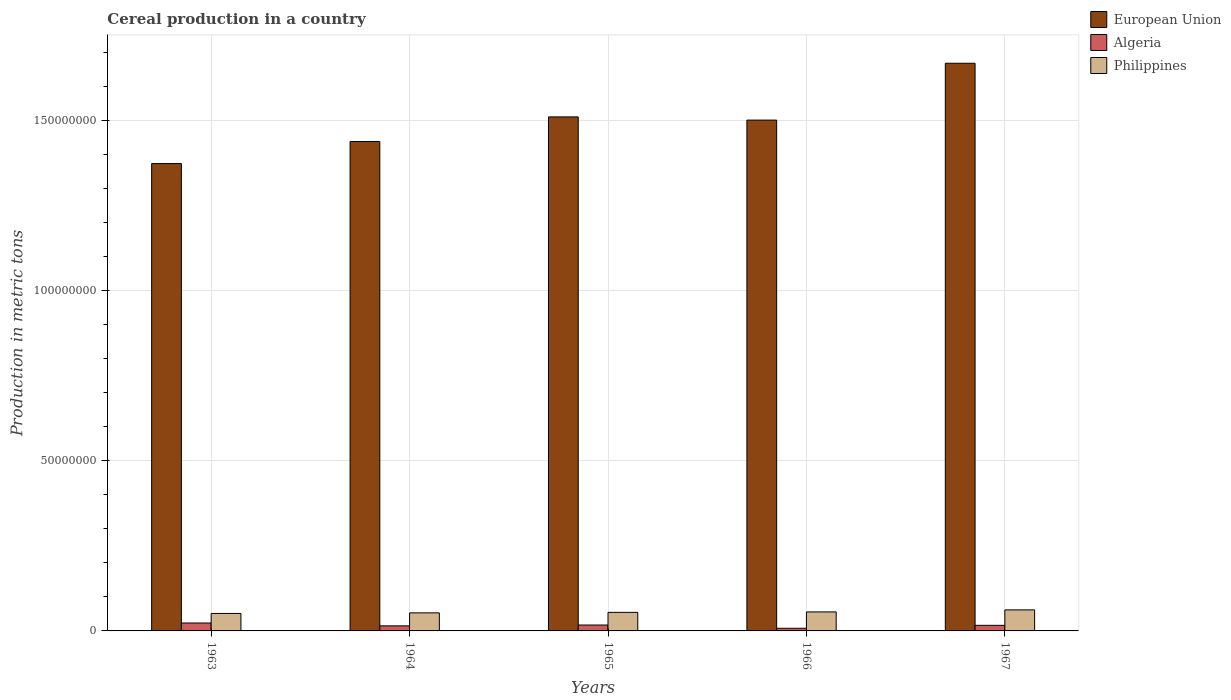How many different coloured bars are there?
Your answer should be compact. 3. Are the number of bars on each tick of the X-axis equal?
Offer a very short reply. Yes. How many bars are there on the 1st tick from the left?
Your response must be concise. 3. How many bars are there on the 2nd tick from the right?
Keep it short and to the point. 3. What is the label of the 3rd group of bars from the left?
Your answer should be compact. 1965. What is the total cereal production in Philippines in 1964?
Keep it short and to the point. 5.31e+06. Across all years, what is the maximum total cereal production in Philippines?
Your answer should be compact. 6.18e+06. Across all years, what is the minimum total cereal production in Philippines?
Your answer should be compact. 5.14e+06. In which year was the total cereal production in Philippines maximum?
Make the answer very short. 1967. What is the total total cereal production in Philippines in the graph?
Ensure brevity in your answer.  2.77e+07. What is the difference between the total cereal production in European Union in 1963 and that in 1966?
Your answer should be very brief. -1.28e+07. What is the difference between the total cereal production in Philippines in 1963 and the total cereal production in Algeria in 1967?
Your answer should be compact. 3.49e+06. What is the average total cereal production in Algeria per year?
Offer a very short reply. 1.59e+06. In the year 1963, what is the difference between the total cereal production in European Union and total cereal production in Philippines?
Make the answer very short. 1.32e+08. In how many years, is the total cereal production in Algeria greater than 60000000 metric tons?
Your response must be concise. 0. What is the ratio of the total cereal production in European Union in 1964 to that in 1965?
Your answer should be very brief. 0.95. Is the difference between the total cereal production in European Union in 1963 and 1965 greater than the difference between the total cereal production in Philippines in 1963 and 1965?
Provide a succinct answer. No. What is the difference between the highest and the second highest total cereal production in Algeria?
Offer a terse response. 5.89e+05. What is the difference between the highest and the lowest total cereal production in European Union?
Offer a terse response. 2.95e+07. Is the sum of the total cereal production in Philippines in 1963 and 1966 greater than the maximum total cereal production in Algeria across all years?
Offer a very short reply. Yes. What does the 2nd bar from the right in 1963 represents?
Ensure brevity in your answer.  Algeria. Is it the case that in every year, the sum of the total cereal production in Philippines and total cereal production in European Union is greater than the total cereal production in Algeria?
Offer a very short reply. Yes. How many years are there in the graph?
Provide a short and direct response. 5. What is the difference between two consecutive major ticks on the Y-axis?
Your answer should be very brief. 5.00e+07. Are the values on the major ticks of Y-axis written in scientific E-notation?
Offer a very short reply. No. Does the graph contain grids?
Make the answer very short. Yes. How many legend labels are there?
Make the answer very short. 3. What is the title of the graph?
Give a very brief answer. Cereal production in a country. Does "Cote d'Ivoire" appear as one of the legend labels in the graph?
Your answer should be very brief. No. What is the label or title of the X-axis?
Offer a very short reply. Years. What is the label or title of the Y-axis?
Your response must be concise. Production in metric tons. What is the Production in metric tons of European Union in 1963?
Your answer should be very brief. 1.37e+08. What is the Production in metric tons in Algeria in 1963?
Keep it short and to the point. 2.32e+06. What is the Production in metric tons of Philippines in 1963?
Keep it short and to the point. 5.14e+06. What is the Production in metric tons of European Union in 1964?
Keep it short and to the point. 1.44e+08. What is the Production in metric tons in Algeria in 1964?
Ensure brevity in your answer.  1.49e+06. What is the Production in metric tons of Philippines in 1964?
Your response must be concise. 5.31e+06. What is the Production in metric tons of European Union in 1965?
Ensure brevity in your answer.  1.51e+08. What is the Production in metric tons in Algeria in 1965?
Your answer should be compact. 1.74e+06. What is the Production in metric tons in Philippines in 1965?
Ensure brevity in your answer.  5.45e+06. What is the Production in metric tons of European Union in 1966?
Provide a short and direct response. 1.50e+08. What is the Production in metric tons in Algeria in 1966?
Your answer should be compact. 7.76e+05. What is the Production in metric tons of Philippines in 1966?
Provide a succinct answer. 5.58e+06. What is the Production in metric tons in European Union in 1967?
Your response must be concise. 1.67e+08. What is the Production in metric tons of Algeria in 1967?
Your response must be concise. 1.64e+06. What is the Production in metric tons of Philippines in 1967?
Offer a very short reply. 6.18e+06. Across all years, what is the maximum Production in metric tons of European Union?
Provide a short and direct response. 1.67e+08. Across all years, what is the maximum Production in metric tons of Algeria?
Offer a terse response. 2.32e+06. Across all years, what is the maximum Production in metric tons in Philippines?
Offer a terse response. 6.18e+06. Across all years, what is the minimum Production in metric tons of European Union?
Ensure brevity in your answer.  1.37e+08. Across all years, what is the minimum Production in metric tons of Algeria?
Provide a short and direct response. 7.76e+05. Across all years, what is the minimum Production in metric tons in Philippines?
Offer a terse response. 5.14e+06. What is the total Production in metric tons in European Union in the graph?
Your response must be concise. 7.49e+08. What is the total Production in metric tons in Algeria in the graph?
Your answer should be compact. 7.97e+06. What is the total Production in metric tons in Philippines in the graph?
Offer a very short reply. 2.77e+07. What is the difference between the Production in metric tons of European Union in 1963 and that in 1964?
Provide a succinct answer. -6.49e+06. What is the difference between the Production in metric tons of Algeria in 1963 and that in 1964?
Keep it short and to the point. 8.37e+05. What is the difference between the Production in metric tons of Philippines in 1963 and that in 1964?
Your answer should be compact. -1.70e+05. What is the difference between the Production in metric tons in European Union in 1963 and that in 1965?
Ensure brevity in your answer.  -1.37e+07. What is the difference between the Production in metric tons of Algeria in 1963 and that in 1965?
Offer a very short reply. 5.89e+05. What is the difference between the Production in metric tons of Philippines in 1963 and that in 1965?
Keep it short and to the point. -3.17e+05. What is the difference between the Production in metric tons in European Union in 1963 and that in 1966?
Provide a succinct answer. -1.28e+07. What is the difference between the Production in metric tons in Algeria in 1963 and that in 1966?
Offer a very short reply. 1.55e+06. What is the difference between the Production in metric tons in Philippines in 1963 and that in 1966?
Your answer should be compact. -4.48e+05. What is the difference between the Production in metric tons of European Union in 1963 and that in 1967?
Your answer should be very brief. -2.95e+07. What is the difference between the Production in metric tons in Algeria in 1963 and that in 1967?
Provide a succinct answer. 6.83e+05. What is the difference between the Production in metric tons in Philippines in 1963 and that in 1967?
Provide a succinct answer. -1.04e+06. What is the difference between the Production in metric tons of European Union in 1964 and that in 1965?
Your answer should be compact. -7.22e+06. What is the difference between the Production in metric tons of Algeria in 1964 and that in 1965?
Your answer should be very brief. -2.48e+05. What is the difference between the Production in metric tons of Philippines in 1964 and that in 1965?
Offer a very short reply. -1.47e+05. What is the difference between the Production in metric tons of European Union in 1964 and that in 1966?
Your response must be concise. -6.28e+06. What is the difference between the Production in metric tons in Algeria in 1964 and that in 1966?
Your answer should be very brief. 7.11e+05. What is the difference between the Production in metric tons of Philippines in 1964 and that in 1966?
Provide a short and direct response. -2.79e+05. What is the difference between the Production in metric tons in European Union in 1964 and that in 1967?
Offer a very short reply. -2.30e+07. What is the difference between the Production in metric tons in Algeria in 1964 and that in 1967?
Provide a short and direct response. -1.54e+05. What is the difference between the Production in metric tons in Philippines in 1964 and that in 1967?
Offer a terse response. -8.75e+05. What is the difference between the Production in metric tons of European Union in 1965 and that in 1966?
Your answer should be compact. 9.40e+05. What is the difference between the Production in metric tons in Algeria in 1965 and that in 1966?
Ensure brevity in your answer.  9.59e+05. What is the difference between the Production in metric tons in Philippines in 1965 and that in 1966?
Your answer should be very brief. -1.32e+05. What is the difference between the Production in metric tons in European Union in 1965 and that in 1967?
Your response must be concise. -1.58e+07. What is the difference between the Production in metric tons of Algeria in 1965 and that in 1967?
Your answer should be compact. 9.38e+04. What is the difference between the Production in metric tons of Philippines in 1965 and that in 1967?
Provide a succinct answer. -7.27e+05. What is the difference between the Production in metric tons in European Union in 1966 and that in 1967?
Offer a terse response. -1.67e+07. What is the difference between the Production in metric tons in Algeria in 1966 and that in 1967?
Your response must be concise. -8.66e+05. What is the difference between the Production in metric tons of Philippines in 1966 and that in 1967?
Make the answer very short. -5.96e+05. What is the difference between the Production in metric tons in European Union in 1963 and the Production in metric tons in Algeria in 1964?
Offer a very short reply. 1.36e+08. What is the difference between the Production in metric tons of European Union in 1963 and the Production in metric tons of Philippines in 1964?
Your answer should be compact. 1.32e+08. What is the difference between the Production in metric tons of Algeria in 1963 and the Production in metric tons of Philippines in 1964?
Give a very brief answer. -2.98e+06. What is the difference between the Production in metric tons in European Union in 1963 and the Production in metric tons in Algeria in 1965?
Provide a succinct answer. 1.36e+08. What is the difference between the Production in metric tons in European Union in 1963 and the Production in metric tons in Philippines in 1965?
Provide a short and direct response. 1.32e+08. What is the difference between the Production in metric tons of Algeria in 1963 and the Production in metric tons of Philippines in 1965?
Your response must be concise. -3.13e+06. What is the difference between the Production in metric tons in European Union in 1963 and the Production in metric tons in Algeria in 1966?
Make the answer very short. 1.37e+08. What is the difference between the Production in metric tons of European Union in 1963 and the Production in metric tons of Philippines in 1966?
Provide a succinct answer. 1.32e+08. What is the difference between the Production in metric tons of Algeria in 1963 and the Production in metric tons of Philippines in 1966?
Your answer should be compact. -3.26e+06. What is the difference between the Production in metric tons of European Union in 1963 and the Production in metric tons of Algeria in 1967?
Ensure brevity in your answer.  1.36e+08. What is the difference between the Production in metric tons of European Union in 1963 and the Production in metric tons of Philippines in 1967?
Make the answer very short. 1.31e+08. What is the difference between the Production in metric tons of Algeria in 1963 and the Production in metric tons of Philippines in 1967?
Provide a succinct answer. -3.86e+06. What is the difference between the Production in metric tons in European Union in 1964 and the Production in metric tons in Algeria in 1965?
Your response must be concise. 1.42e+08. What is the difference between the Production in metric tons in European Union in 1964 and the Production in metric tons in Philippines in 1965?
Offer a terse response. 1.38e+08. What is the difference between the Production in metric tons in Algeria in 1964 and the Production in metric tons in Philippines in 1965?
Keep it short and to the point. -3.96e+06. What is the difference between the Production in metric tons of European Union in 1964 and the Production in metric tons of Algeria in 1966?
Ensure brevity in your answer.  1.43e+08. What is the difference between the Production in metric tons of European Union in 1964 and the Production in metric tons of Philippines in 1966?
Ensure brevity in your answer.  1.38e+08. What is the difference between the Production in metric tons in Algeria in 1964 and the Production in metric tons in Philippines in 1966?
Keep it short and to the point. -4.10e+06. What is the difference between the Production in metric tons of European Union in 1964 and the Production in metric tons of Algeria in 1967?
Keep it short and to the point. 1.42e+08. What is the difference between the Production in metric tons in European Union in 1964 and the Production in metric tons in Philippines in 1967?
Provide a short and direct response. 1.38e+08. What is the difference between the Production in metric tons in Algeria in 1964 and the Production in metric tons in Philippines in 1967?
Your answer should be very brief. -4.69e+06. What is the difference between the Production in metric tons of European Union in 1965 and the Production in metric tons of Algeria in 1966?
Keep it short and to the point. 1.50e+08. What is the difference between the Production in metric tons in European Union in 1965 and the Production in metric tons in Philippines in 1966?
Offer a very short reply. 1.45e+08. What is the difference between the Production in metric tons of Algeria in 1965 and the Production in metric tons of Philippines in 1966?
Provide a succinct answer. -3.85e+06. What is the difference between the Production in metric tons of European Union in 1965 and the Production in metric tons of Algeria in 1967?
Your answer should be very brief. 1.49e+08. What is the difference between the Production in metric tons of European Union in 1965 and the Production in metric tons of Philippines in 1967?
Offer a very short reply. 1.45e+08. What is the difference between the Production in metric tons in Algeria in 1965 and the Production in metric tons in Philippines in 1967?
Make the answer very short. -4.44e+06. What is the difference between the Production in metric tons in European Union in 1966 and the Production in metric tons in Algeria in 1967?
Ensure brevity in your answer.  1.48e+08. What is the difference between the Production in metric tons in European Union in 1966 and the Production in metric tons in Philippines in 1967?
Keep it short and to the point. 1.44e+08. What is the difference between the Production in metric tons of Algeria in 1966 and the Production in metric tons of Philippines in 1967?
Your response must be concise. -5.40e+06. What is the average Production in metric tons in European Union per year?
Your answer should be compact. 1.50e+08. What is the average Production in metric tons in Algeria per year?
Offer a very short reply. 1.59e+06. What is the average Production in metric tons in Philippines per year?
Your answer should be compact. 5.53e+06. In the year 1963, what is the difference between the Production in metric tons in European Union and Production in metric tons in Algeria?
Offer a very short reply. 1.35e+08. In the year 1963, what is the difference between the Production in metric tons of European Union and Production in metric tons of Philippines?
Ensure brevity in your answer.  1.32e+08. In the year 1963, what is the difference between the Production in metric tons in Algeria and Production in metric tons in Philippines?
Give a very brief answer. -2.81e+06. In the year 1964, what is the difference between the Production in metric tons of European Union and Production in metric tons of Algeria?
Provide a short and direct response. 1.42e+08. In the year 1964, what is the difference between the Production in metric tons of European Union and Production in metric tons of Philippines?
Keep it short and to the point. 1.39e+08. In the year 1964, what is the difference between the Production in metric tons of Algeria and Production in metric tons of Philippines?
Offer a very short reply. -3.82e+06. In the year 1965, what is the difference between the Production in metric tons in European Union and Production in metric tons in Algeria?
Make the answer very short. 1.49e+08. In the year 1965, what is the difference between the Production in metric tons in European Union and Production in metric tons in Philippines?
Your answer should be very brief. 1.46e+08. In the year 1965, what is the difference between the Production in metric tons in Algeria and Production in metric tons in Philippines?
Your response must be concise. -3.72e+06. In the year 1966, what is the difference between the Production in metric tons in European Union and Production in metric tons in Algeria?
Your answer should be very brief. 1.49e+08. In the year 1966, what is the difference between the Production in metric tons of European Union and Production in metric tons of Philippines?
Make the answer very short. 1.45e+08. In the year 1966, what is the difference between the Production in metric tons in Algeria and Production in metric tons in Philippines?
Your answer should be compact. -4.81e+06. In the year 1967, what is the difference between the Production in metric tons of European Union and Production in metric tons of Algeria?
Ensure brevity in your answer.  1.65e+08. In the year 1967, what is the difference between the Production in metric tons in European Union and Production in metric tons in Philippines?
Provide a succinct answer. 1.61e+08. In the year 1967, what is the difference between the Production in metric tons in Algeria and Production in metric tons in Philippines?
Make the answer very short. -4.54e+06. What is the ratio of the Production in metric tons of European Union in 1963 to that in 1964?
Ensure brevity in your answer.  0.95. What is the ratio of the Production in metric tons in Algeria in 1963 to that in 1964?
Offer a very short reply. 1.56. What is the ratio of the Production in metric tons in Philippines in 1963 to that in 1964?
Ensure brevity in your answer.  0.97. What is the ratio of the Production in metric tons of European Union in 1963 to that in 1965?
Ensure brevity in your answer.  0.91. What is the ratio of the Production in metric tons of Algeria in 1963 to that in 1965?
Your response must be concise. 1.34. What is the ratio of the Production in metric tons in Philippines in 1963 to that in 1965?
Offer a terse response. 0.94. What is the ratio of the Production in metric tons of European Union in 1963 to that in 1966?
Provide a succinct answer. 0.91. What is the ratio of the Production in metric tons of Algeria in 1963 to that in 1966?
Give a very brief answer. 2.99. What is the ratio of the Production in metric tons in Philippines in 1963 to that in 1966?
Provide a short and direct response. 0.92. What is the ratio of the Production in metric tons of European Union in 1963 to that in 1967?
Your answer should be compact. 0.82. What is the ratio of the Production in metric tons in Algeria in 1963 to that in 1967?
Your answer should be very brief. 1.42. What is the ratio of the Production in metric tons in Philippines in 1963 to that in 1967?
Provide a succinct answer. 0.83. What is the ratio of the Production in metric tons of European Union in 1964 to that in 1965?
Provide a succinct answer. 0.95. What is the ratio of the Production in metric tons of European Union in 1964 to that in 1966?
Provide a succinct answer. 0.96. What is the ratio of the Production in metric tons of Algeria in 1964 to that in 1966?
Provide a short and direct response. 1.92. What is the ratio of the Production in metric tons of Philippines in 1964 to that in 1966?
Keep it short and to the point. 0.95. What is the ratio of the Production in metric tons in European Union in 1964 to that in 1967?
Your response must be concise. 0.86. What is the ratio of the Production in metric tons of Algeria in 1964 to that in 1967?
Your answer should be very brief. 0.91. What is the ratio of the Production in metric tons of Philippines in 1964 to that in 1967?
Your response must be concise. 0.86. What is the ratio of the Production in metric tons in Algeria in 1965 to that in 1966?
Make the answer very short. 2.24. What is the ratio of the Production in metric tons of Philippines in 1965 to that in 1966?
Give a very brief answer. 0.98. What is the ratio of the Production in metric tons of European Union in 1965 to that in 1967?
Your answer should be compact. 0.91. What is the ratio of the Production in metric tons in Algeria in 1965 to that in 1967?
Make the answer very short. 1.06. What is the ratio of the Production in metric tons in Philippines in 1965 to that in 1967?
Offer a terse response. 0.88. What is the ratio of the Production in metric tons in European Union in 1966 to that in 1967?
Make the answer very short. 0.9. What is the ratio of the Production in metric tons in Algeria in 1966 to that in 1967?
Give a very brief answer. 0.47. What is the ratio of the Production in metric tons of Philippines in 1966 to that in 1967?
Give a very brief answer. 0.9. What is the difference between the highest and the second highest Production in metric tons of European Union?
Provide a succinct answer. 1.58e+07. What is the difference between the highest and the second highest Production in metric tons of Algeria?
Provide a short and direct response. 5.89e+05. What is the difference between the highest and the second highest Production in metric tons in Philippines?
Your answer should be compact. 5.96e+05. What is the difference between the highest and the lowest Production in metric tons of European Union?
Keep it short and to the point. 2.95e+07. What is the difference between the highest and the lowest Production in metric tons in Algeria?
Make the answer very short. 1.55e+06. What is the difference between the highest and the lowest Production in metric tons in Philippines?
Your answer should be very brief. 1.04e+06. 